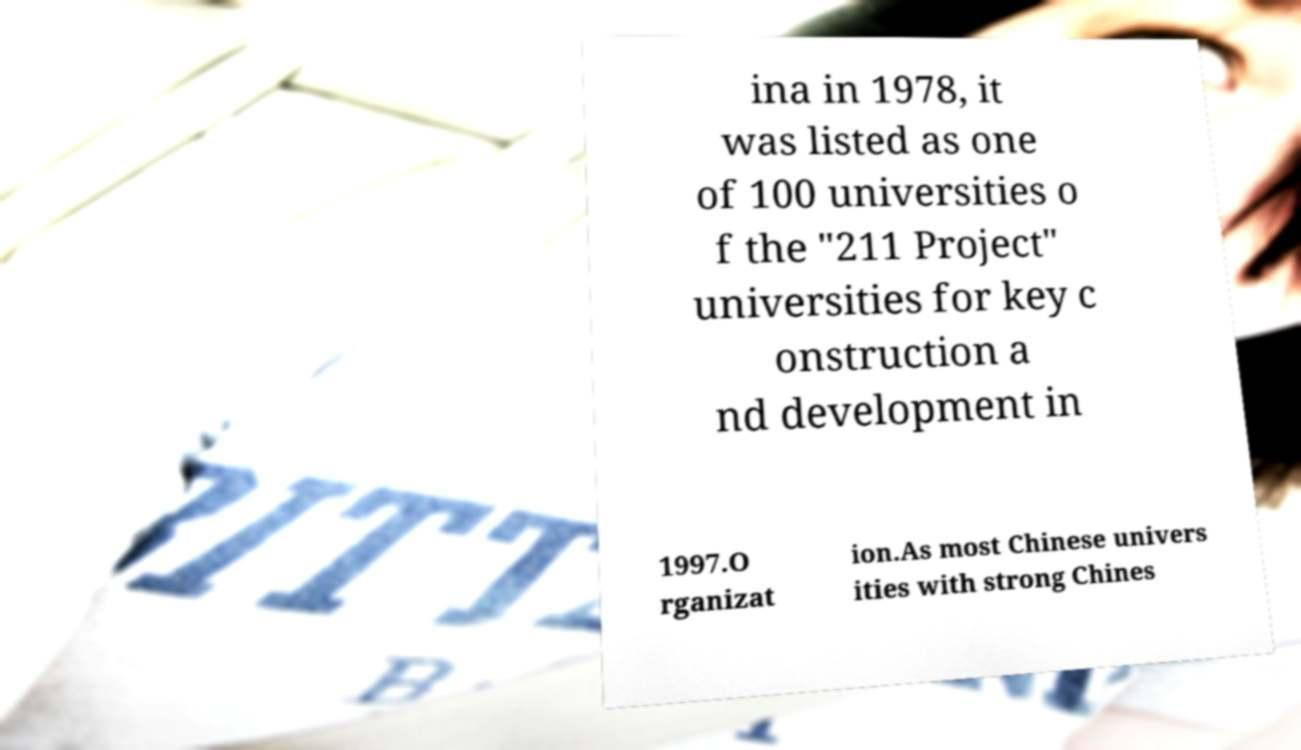Can you read and provide the text displayed in the image?This photo seems to have some interesting text. Can you extract and type it out for me? ina in 1978, it was listed as one of 100 universities o f the "211 Project" universities for key c onstruction a nd development in 1997.O rganizat ion.As most Chinese univers ities with strong Chines 